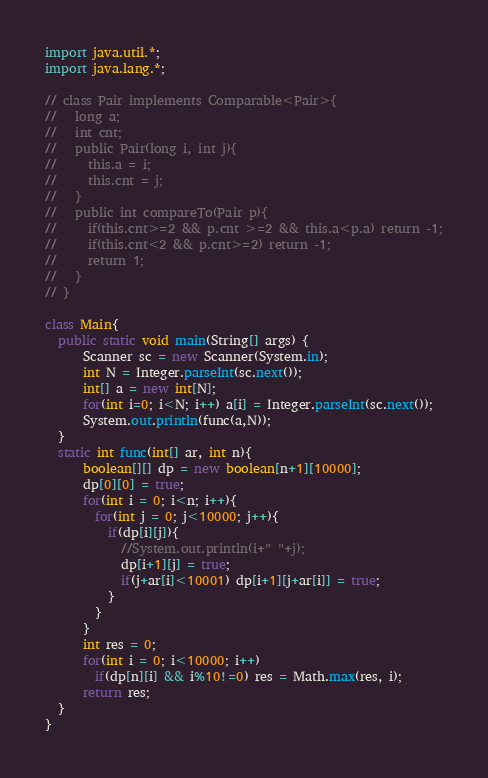Convert code to text. <code><loc_0><loc_0><loc_500><loc_500><_Java_>import java.util.*;
import java.lang.*;
 
// class Pair implements Comparable<Pair>{
//   long a;
//   int cnt;
//   public Pair(long i, int j){
//     this.a = i;
//     this.cnt = j;
//   }
//   public int compareTo(Pair p){
//     if(this.cnt>=2 && p.cnt >=2 && this.a<p.a) return -1;
//     if(this.cnt<2 && p.cnt>=2) return -1;
//     return 1;
//   }
// }
 
class Main{
  public static void main(String[] args) {
      Scanner sc = new Scanner(System.in);
      int N = Integer.parseInt(sc.next());
      int[] a = new int[N];
      for(int i=0; i<N; i++) a[i] = Integer.parseInt(sc.next());
      System.out.println(func(a,N));
  }
  static int func(int[] ar, int n){
      boolean[][] dp = new boolean[n+1][10000];
      dp[0][0] = true;
      for(int i = 0; i<n; i++){
        for(int j = 0; j<10000; j++){
          if(dp[i][j]){
            //System.out.println(i+" "+j);
            dp[i+1][j] = true;
            if(j+ar[i]<10001) dp[i+1][j+ar[i]] = true;
          }
        }
      }
      int res = 0;
      for(int i = 0; i<10000; i++)
        if(dp[n][i] && i%10!=0) res = Math.max(res, i);
      return res;
  }
}</code> 